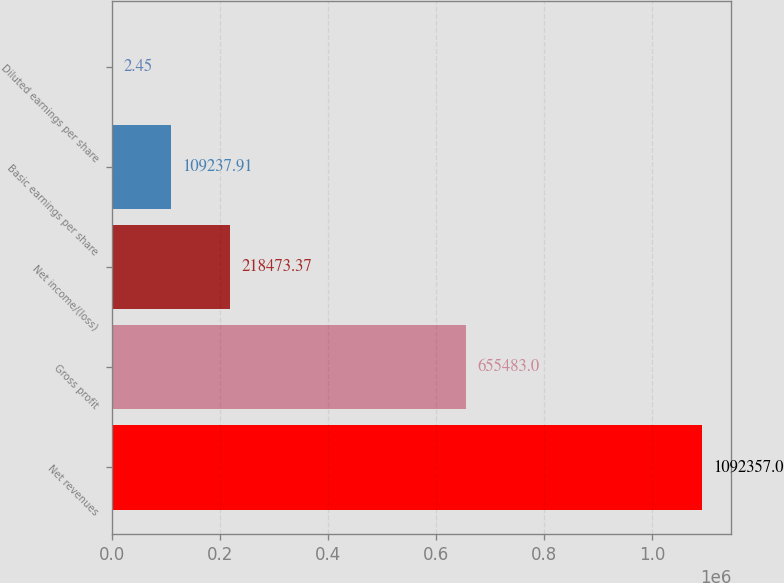Convert chart. <chart><loc_0><loc_0><loc_500><loc_500><bar_chart><fcel>Net revenues<fcel>Gross profit<fcel>Net income/(loss)<fcel>Basic earnings per share<fcel>Diluted earnings per share<nl><fcel>1.09236e+06<fcel>655483<fcel>218473<fcel>109238<fcel>2.45<nl></chart> 